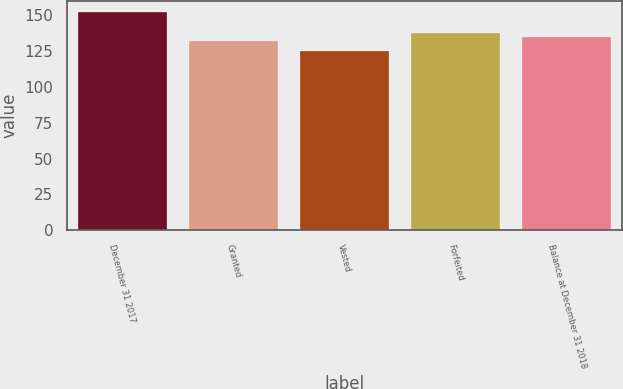Convert chart to OTSL. <chart><loc_0><loc_0><loc_500><loc_500><bar_chart><fcel>December 31 2017<fcel>Granted<fcel>Vested<fcel>Forfeited<fcel>Balance at December 31 2018<nl><fcel>152.61<fcel>132.23<fcel>125.38<fcel>137.83<fcel>134.95<nl></chart> 